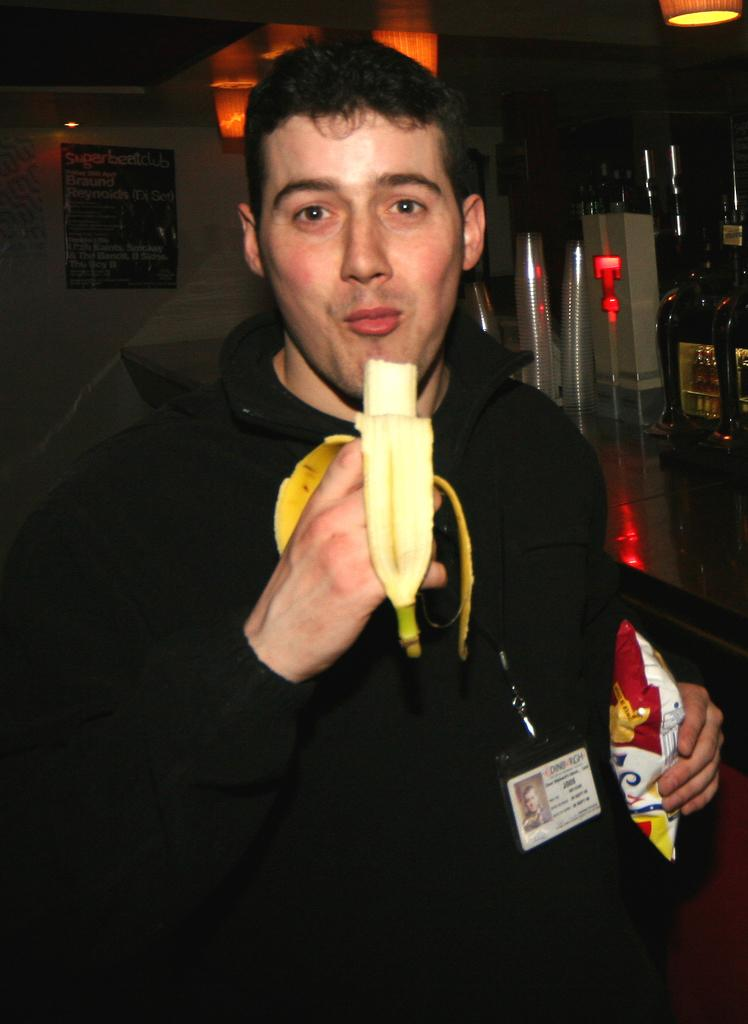What is the man in the center of the image doing? The man is standing in the center of the image and holding a banana. What can be seen in the background of the image? There is a table, bottles, glasses, a poster, and a wall in the background of the image. What is the man holding in his hand? The man is holding a banana. Can you describe the objects on the table in the background? The provided facts do not mention any details about the objects on the table. What type of letter is the owl delivering in the image? There is no owl or letter present in the image. What type of polish is being used on the table in the image? There is no mention of polish or any activity related to polishing in the image. 